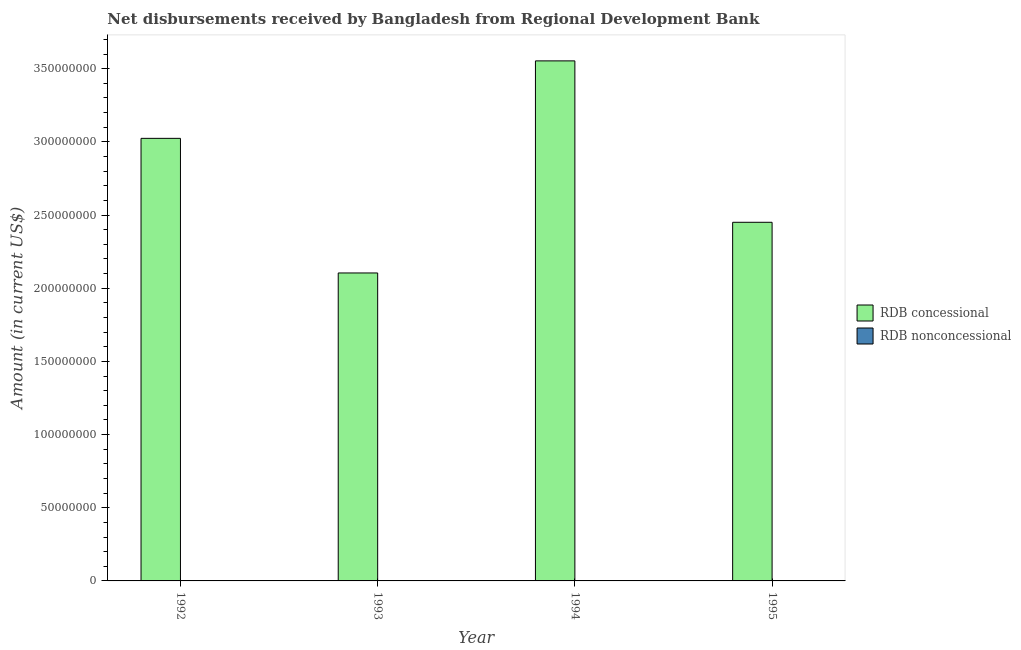How many different coloured bars are there?
Your answer should be very brief. 1. Are the number of bars per tick equal to the number of legend labels?
Make the answer very short. No. What is the net concessional disbursements from rdb in 1994?
Provide a succinct answer. 3.55e+08. Across all years, what is the maximum net concessional disbursements from rdb?
Your answer should be very brief. 3.55e+08. What is the total net concessional disbursements from rdb in the graph?
Offer a very short reply. 1.11e+09. What is the difference between the net concessional disbursements from rdb in 1993 and that in 1994?
Make the answer very short. -1.45e+08. What is the average net concessional disbursements from rdb per year?
Make the answer very short. 2.78e+08. In how many years, is the net concessional disbursements from rdb greater than 170000000 US$?
Provide a succinct answer. 4. What is the ratio of the net concessional disbursements from rdb in 1992 to that in 1995?
Your response must be concise. 1.23. What is the difference between the highest and the second highest net concessional disbursements from rdb?
Provide a succinct answer. 5.29e+07. What is the difference between the highest and the lowest net concessional disbursements from rdb?
Make the answer very short. 1.45e+08. Is the sum of the net concessional disbursements from rdb in 1992 and 1993 greater than the maximum net non concessional disbursements from rdb across all years?
Your response must be concise. Yes. How many bars are there?
Your answer should be very brief. 4. Are all the bars in the graph horizontal?
Provide a short and direct response. No. Are the values on the major ticks of Y-axis written in scientific E-notation?
Provide a succinct answer. No. Does the graph contain any zero values?
Provide a short and direct response. Yes. Does the graph contain grids?
Give a very brief answer. No. Where does the legend appear in the graph?
Make the answer very short. Center right. How are the legend labels stacked?
Offer a terse response. Vertical. What is the title of the graph?
Give a very brief answer. Net disbursements received by Bangladesh from Regional Development Bank. What is the label or title of the Y-axis?
Your response must be concise. Amount (in current US$). What is the Amount (in current US$) of RDB concessional in 1992?
Offer a very short reply. 3.02e+08. What is the Amount (in current US$) of RDB nonconcessional in 1992?
Make the answer very short. 0. What is the Amount (in current US$) of RDB concessional in 1993?
Ensure brevity in your answer.  2.10e+08. What is the Amount (in current US$) in RDB concessional in 1994?
Offer a terse response. 3.55e+08. What is the Amount (in current US$) of RDB nonconcessional in 1994?
Make the answer very short. 0. What is the Amount (in current US$) in RDB concessional in 1995?
Your answer should be very brief. 2.45e+08. Across all years, what is the maximum Amount (in current US$) in RDB concessional?
Make the answer very short. 3.55e+08. Across all years, what is the minimum Amount (in current US$) in RDB concessional?
Offer a terse response. 2.10e+08. What is the total Amount (in current US$) in RDB concessional in the graph?
Offer a very short reply. 1.11e+09. What is the total Amount (in current US$) of RDB nonconcessional in the graph?
Your response must be concise. 0. What is the difference between the Amount (in current US$) of RDB concessional in 1992 and that in 1993?
Make the answer very short. 9.20e+07. What is the difference between the Amount (in current US$) of RDB concessional in 1992 and that in 1994?
Offer a very short reply. -5.29e+07. What is the difference between the Amount (in current US$) of RDB concessional in 1992 and that in 1995?
Provide a short and direct response. 5.74e+07. What is the difference between the Amount (in current US$) of RDB concessional in 1993 and that in 1994?
Give a very brief answer. -1.45e+08. What is the difference between the Amount (in current US$) of RDB concessional in 1993 and that in 1995?
Offer a terse response. -3.46e+07. What is the difference between the Amount (in current US$) of RDB concessional in 1994 and that in 1995?
Your response must be concise. 1.10e+08. What is the average Amount (in current US$) of RDB concessional per year?
Provide a short and direct response. 2.78e+08. What is the average Amount (in current US$) of RDB nonconcessional per year?
Ensure brevity in your answer.  0. What is the ratio of the Amount (in current US$) of RDB concessional in 1992 to that in 1993?
Your response must be concise. 1.44. What is the ratio of the Amount (in current US$) in RDB concessional in 1992 to that in 1994?
Your answer should be very brief. 0.85. What is the ratio of the Amount (in current US$) in RDB concessional in 1992 to that in 1995?
Offer a terse response. 1.23. What is the ratio of the Amount (in current US$) in RDB concessional in 1993 to that in 1994?
Your response must be concise. 0.59. What is the ratio of the Amount (in current US$) of RDB concessional in 1993 to that in 1995?
Keep it short and to the point. 0.86. What is the ratio of the Amount (in current US$) in RDB concessional in 1994 to that in 1995?
Make the answer very short. 1.45. What is the difference between the highest and the second highest Amount (in current US$) of RDB concessional?
Make the answer very short. 5.29e+07. What is the difference between the highest and the lowest Amount (in current US$) of RDB concessional?
Your answer should be compact. 1.45e+08. 